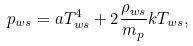Convert formula to latex. <formula><loc_0><loc_0><loc_500><loc_500>p _ { w s } = a T _ { w s } ^ { 4 } + 2 \frac { \rho _ { w s } } { m _ { p } } k T _ { w s } ,</formula> 